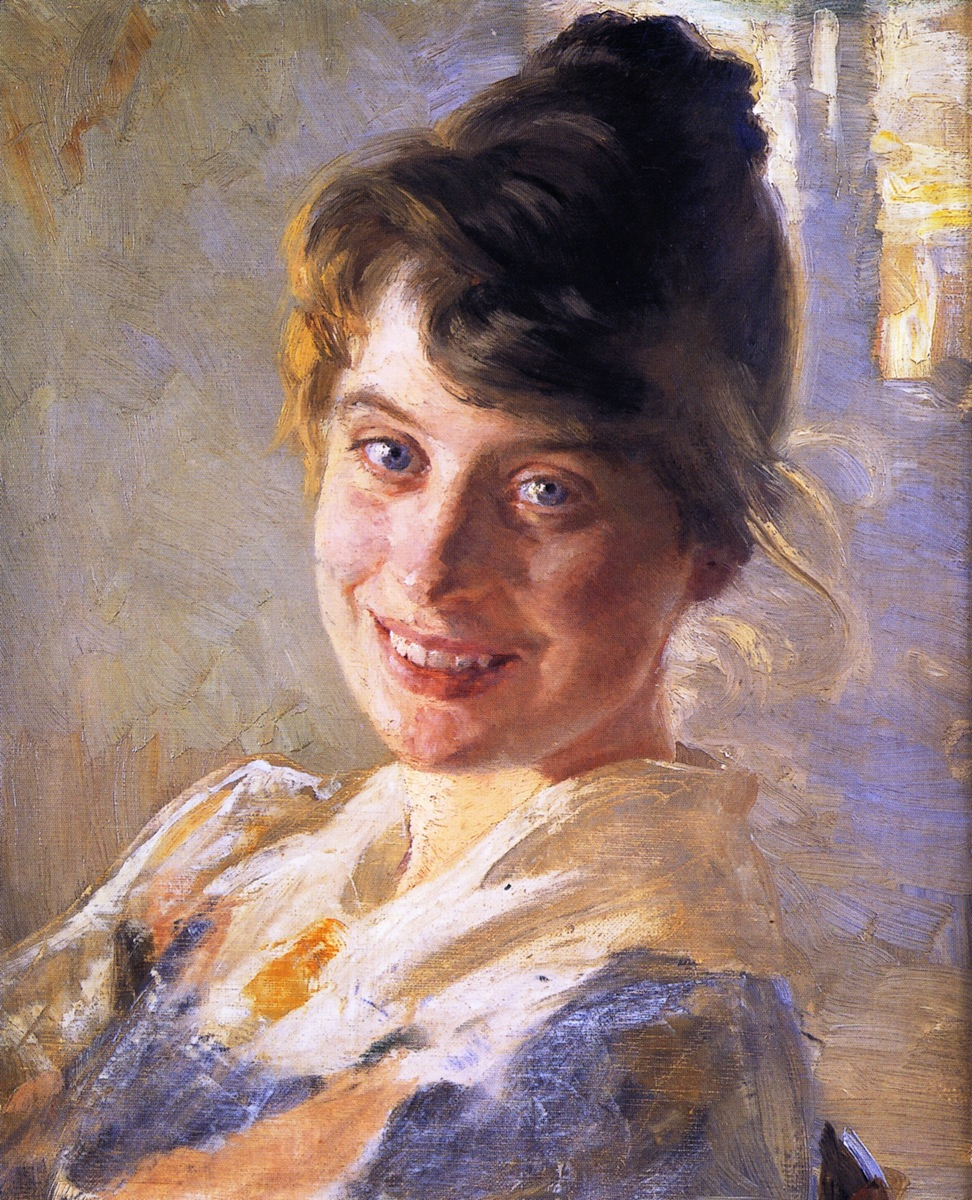Describe the emotions conveyed by the woman's expression. The woman's expression is radiant with joy and warmth. Her gentle smile and bright eyes convey a sense of happiness and contentment. The overall effect of her expression is inviting and uplifting, suggesting that she is experiencing a moment of genuine pleasure or connection. What might be the story behind this portrait? The portrait could be capturing a moment of happiness in the young woman’s life. She might be posing for the artist, who could be a loved one or a close friend, which would explain the natural and relaxed expression. The use of light and color indicates a warm environment, possibly hinting at personal and intimate moments shared in a cozy setting. The bun hairstyle and blouse suggest a timeless elegance, hinting at her gentle nature and cheerful disposition. Imagine if the backdrop were replaced with a vivid meadow. What changes would that bring to the piece? If the backdrop were to be replaced with a vivid meadow, the painting would take on an entirely different dimension. The lush greens, sprinkled with vibrant wildflowers, would add an element of nature and freedom. It could imply that the young woman is enjoying a moment outdoors, enveloped by the beauty of the meadow. This change would heighten the sense of cheerfulness, vitality, and connection with nature, and might make the overall mood even more relaxing and joyful. Let's get wildly creative: What if this woman was a character in a fantasy world? Describe her role and surroundings. In a fantastical realm, this woman could be a revered Healer of the Elven kingdom, known for her incredible ability to mend both the body and spirit. Her smile radiates a magical aura that brings calm and happiness to all who see it. She resides in the Elderglades, a mystical forest where the trees glow softly and the air is filled with the lights of fireflies and enchanted creatures. Her attire is made from the finest silken threads spun by moonlight spiders, adorned with ethereal blue patterns that shift and shimmer with her healing powers. Every morning, she collects dew from the sacred flowers in the forest, using it to prepare potions and elixirs that can cure any ailment. The serene meadow and her legendary hair, often bound in a loose, flowing bun, bespeak hope and rejuvenation. Her presence is cherished, symbolizing a beacon of light in the most fantastical of lands. 